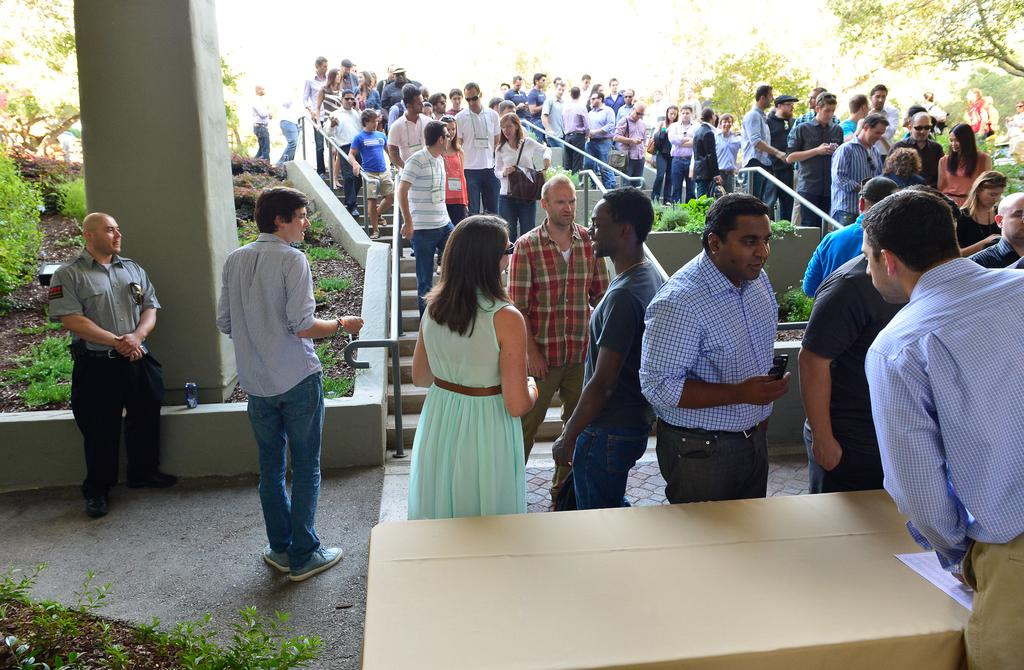Where was the image taken? The image was taken outdoors. What can be seen in the image in terms of people? There is a group of people standing in the image. What surface are the people standing on? The people are standing on the floor. What furniture is present in the image? There is a table in the image. What is on the table? There is a paper on the table. What type of grain is being distributed to the people in the image? There is no grain or distribution activity present in the image. What color is the jelly on the table in the image? There is no jelly present in the image; it is a paper on the table. 